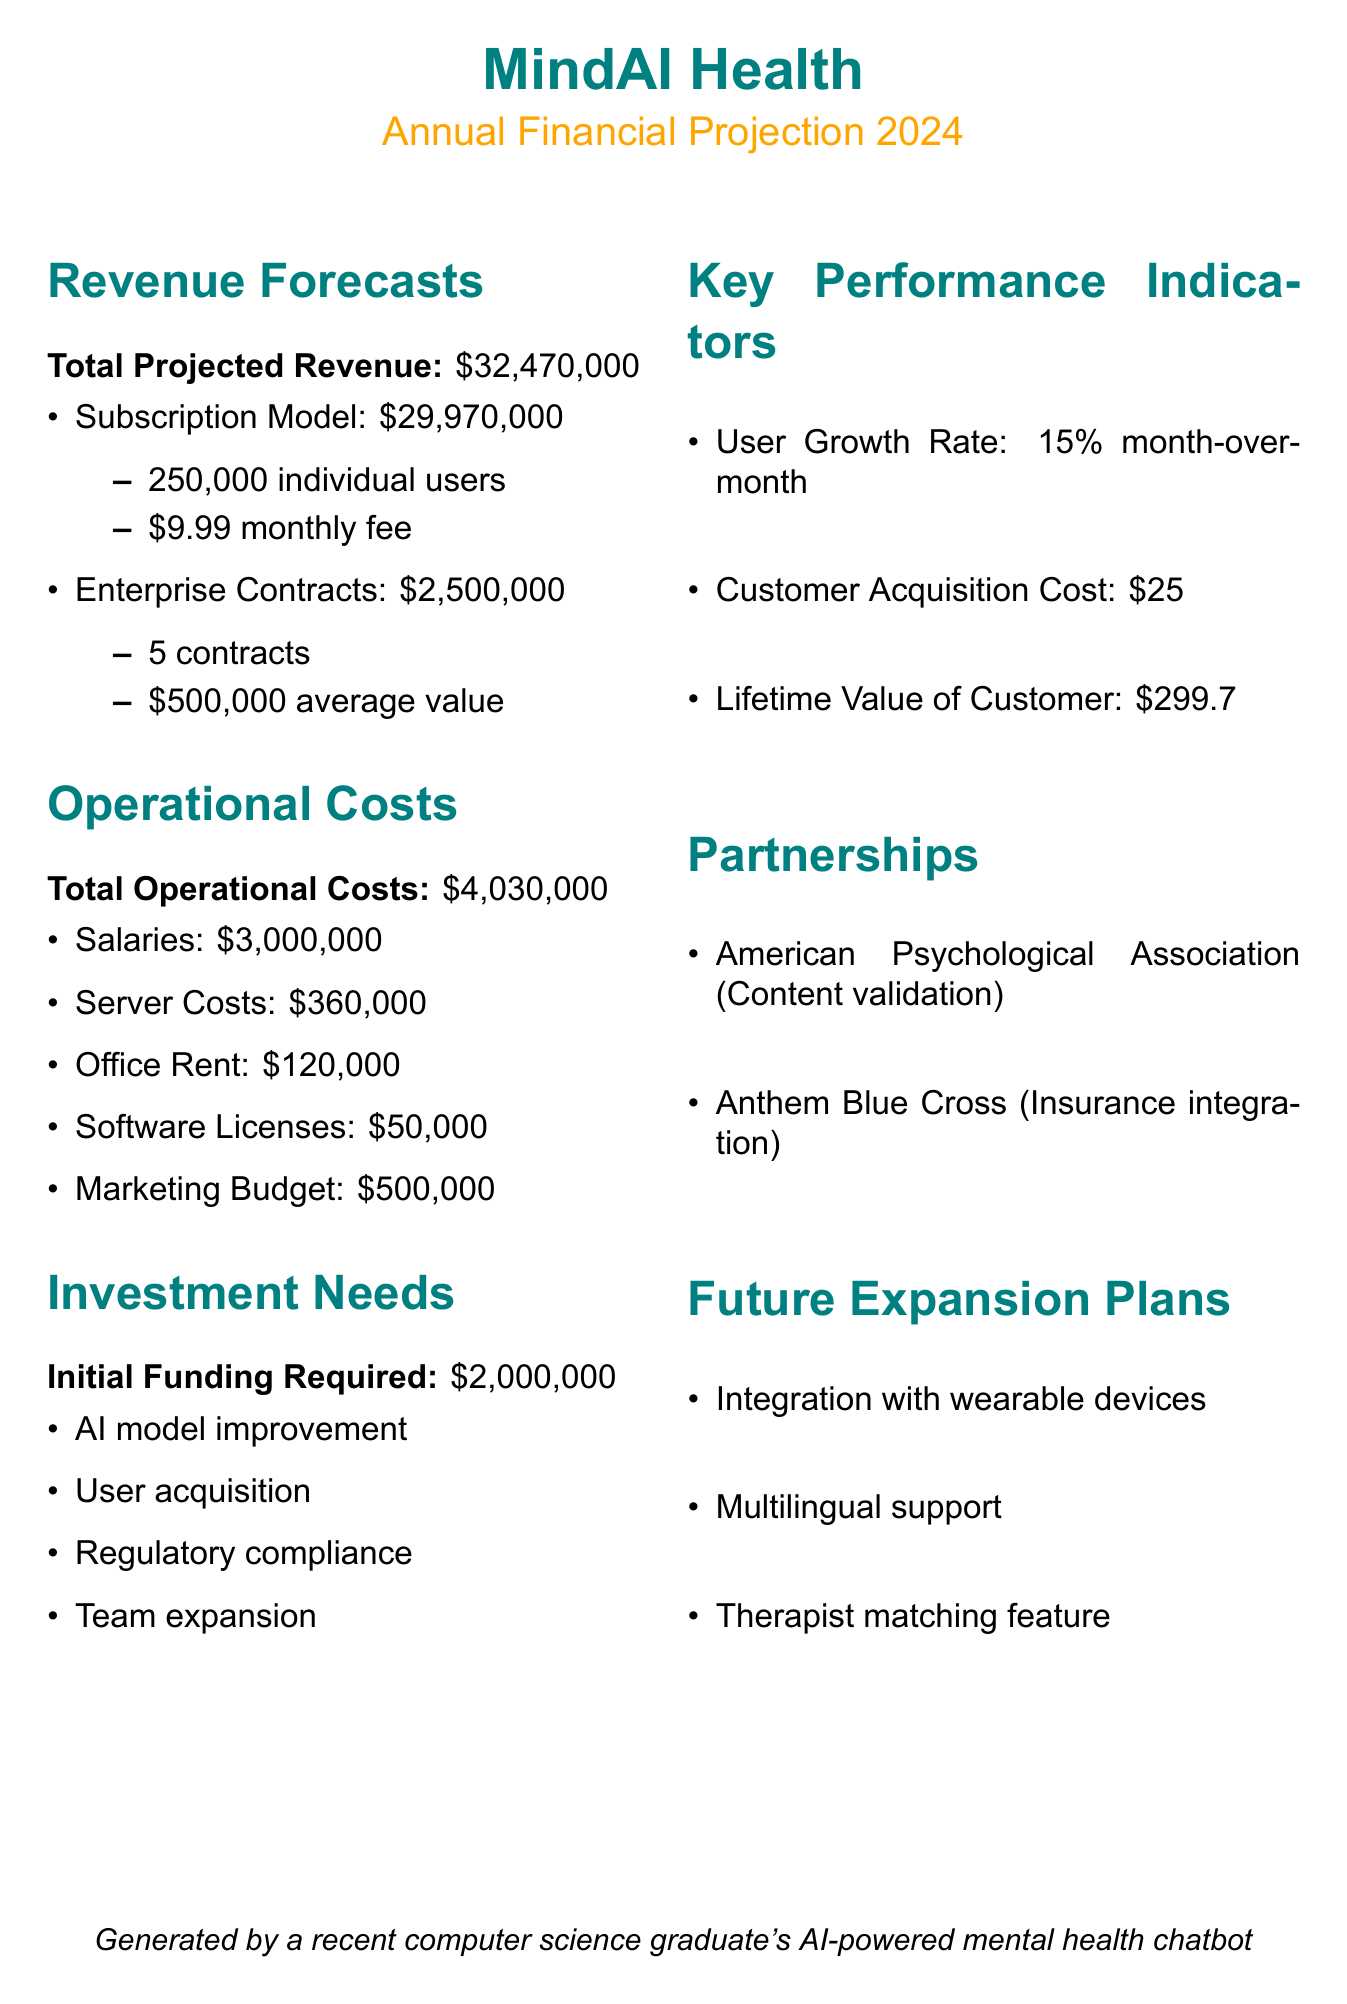what is the total projected revenue? The total projected revenue is mentioned in the revenue forecasts section, which sums the subscription model and enterprise contracts.
Answer: 32,470,000 how many individual users are expected? The document specifies that the subscription model forecasts 250,000 individual users.
Answer: 250,000 what is the total operational costs? The document lists the total operational costs as the sum of all costs outlined in the operational costs section.
Answer: 4,030,000 what is the initial funding required? The amount needed for initial funding is clearly stated in the investment needs section.
Answer: 2,000,000 who is the insurance integration partner? The partnerships section lists Anthem Blue Cross as the insurance integration partner.
Answer: Anthem Blue Cross what is the user growth rate? The user growth rate is provided in the key performance indicators section, indicating the month-over-month increase.
Answer: 15% month-over-month what is the average contract value for enterprise contracts? The enterprise contract section mentions the average contract value of each contract.
Answer: 500,000 which feature is planned for future expansion related to support? The future expansion plans include one feature related to support mentioned in the document.
Answer: Multilingual support what percentage of the operational costs is allocated to salaries? The document lists total operational costs and individual salary costs, allowing for calculation.
Answer: 74.4% 